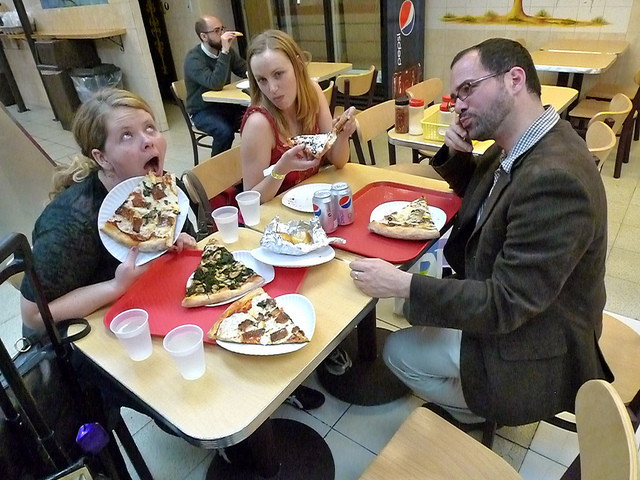How many chairs can you see? From this angle, it's clear there are at least three chairs visible, occupied by the three individuals enjoying their meal. 